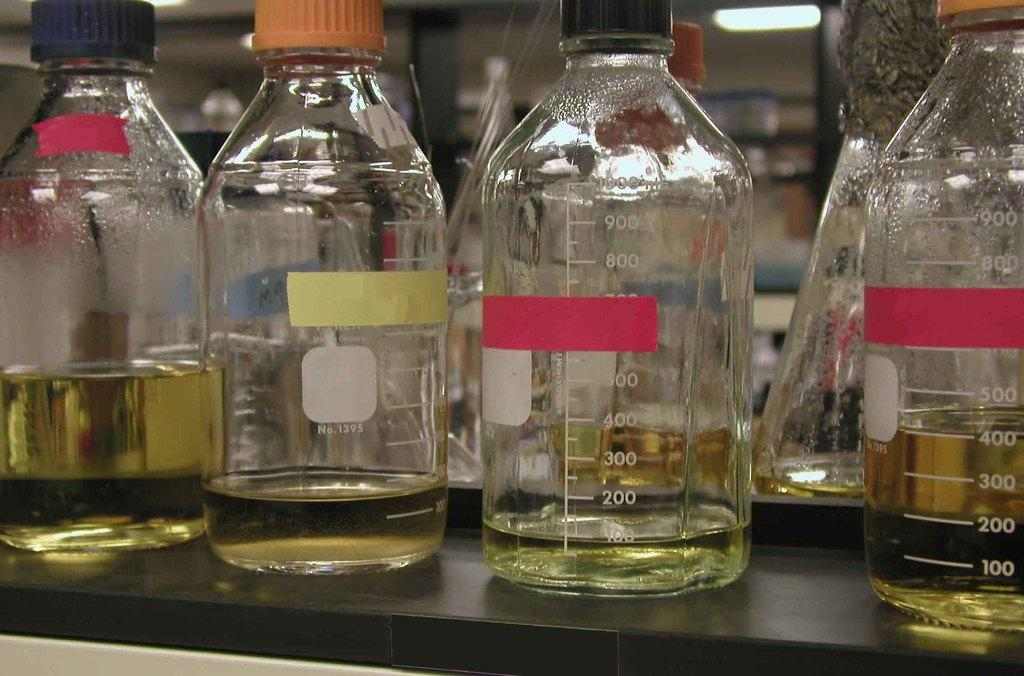<image>
Offer a succinct explanation of the picture presented. Four measuring bottles one with red tap covering the 700 ml number. 